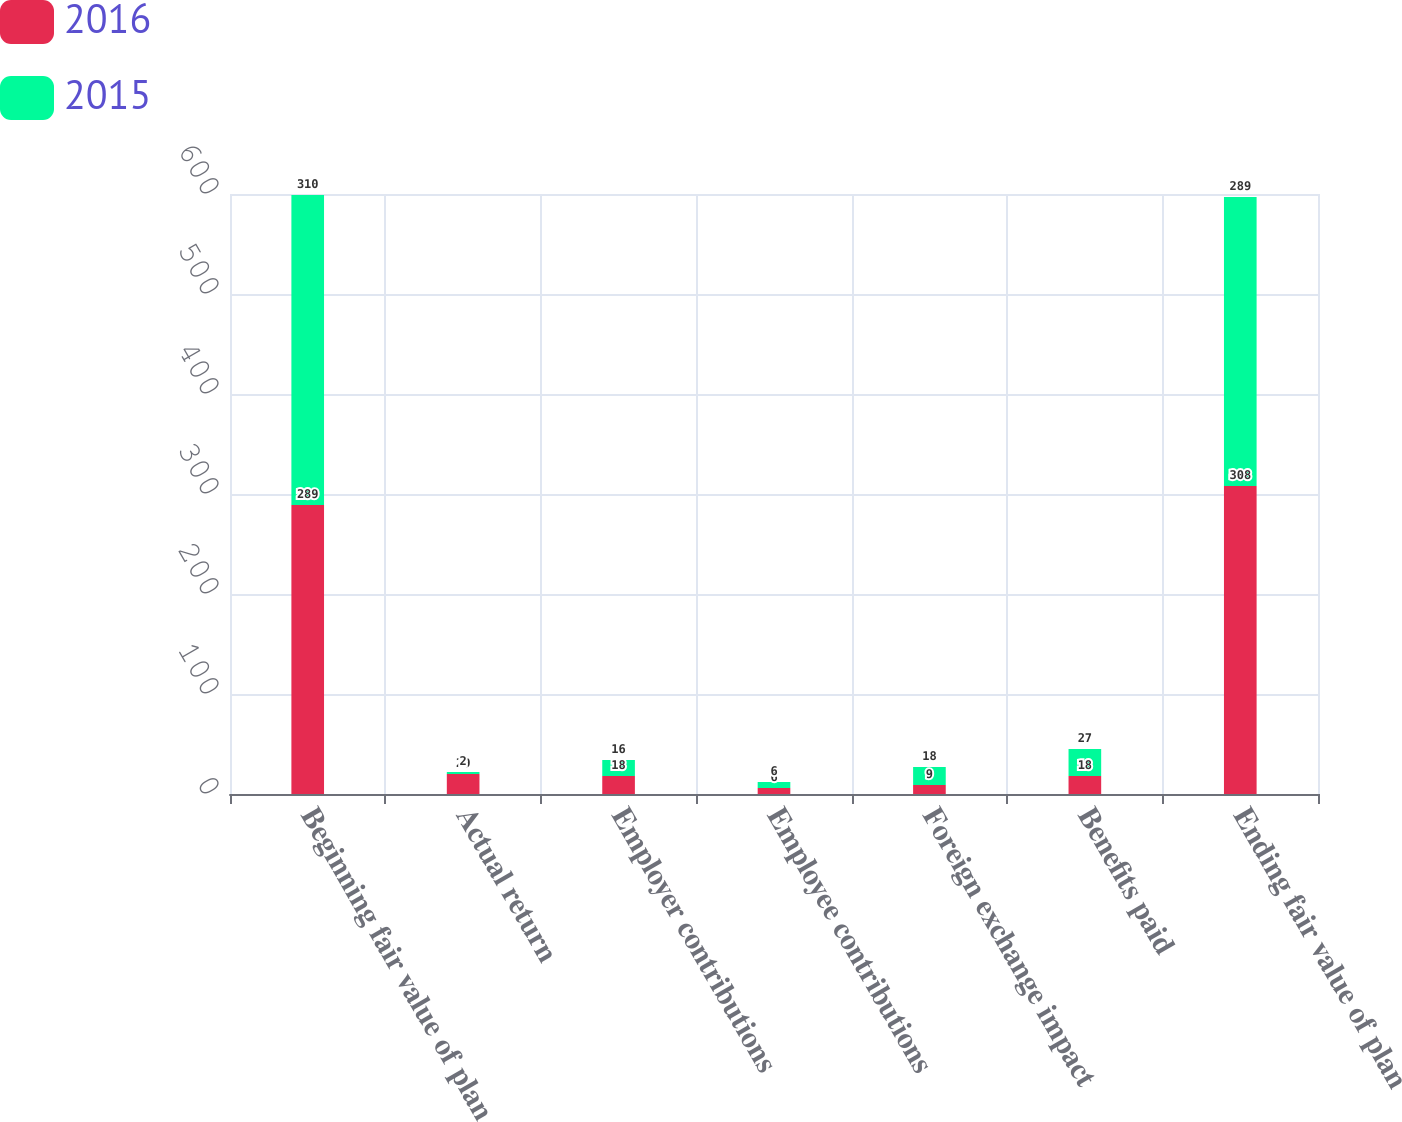Convert chart to OTSL. <chart><loc_0><loc_0><loc_500><loc_500><stacked_bar_chart><ecel><fcel>Beginning fair value of plan<fcel>Actual return<fcel>Employer contributions<fcel>Employee contributions<fcel>Foreign exchange impact<fcel>Benefits paid<fcel>Ending fair value of plan<nl><fcel>2016<fcel>289<fcel>20<fcel>18<fcel>6<fcel>9<fcel>18<fcel>308<nl><fcel>2015<fcel>310<fcel>2<fcel>16<fcel>6<fcel>18<fcel>27<fcel>289<nl></chart> 